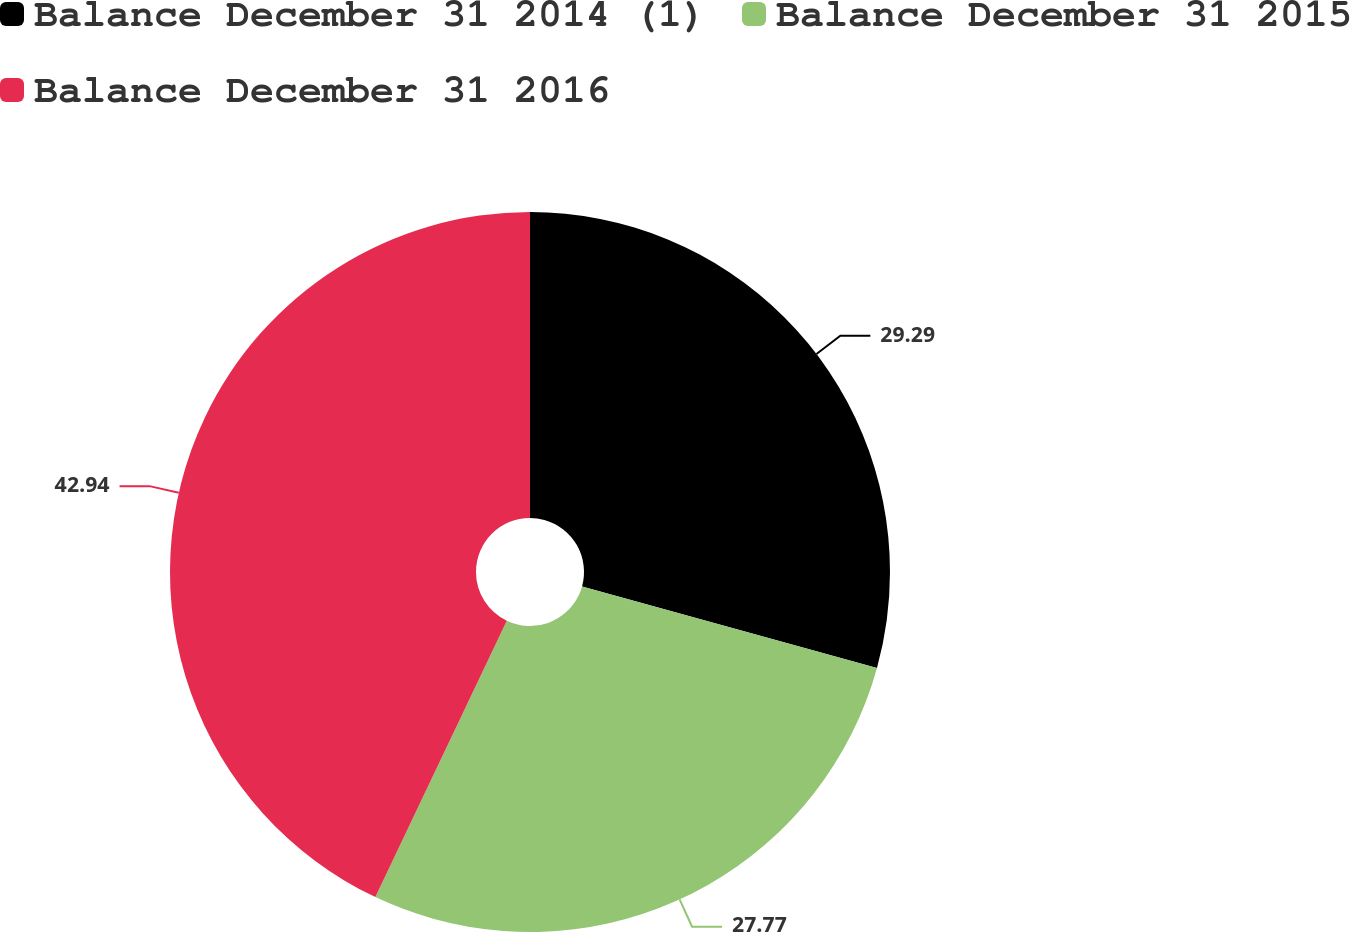Convert chart to OTSL. <chart><loc_0><loc_0><loc_500><loc_500><pie_chart><fcel>Balance December 31 2014 (1)<fcel>Balance December 31 2015<fcel>Balance December 31 2016<nl><fcel>29.29%<fcel>27.77%<fcel>42.93%<nl></chart> 